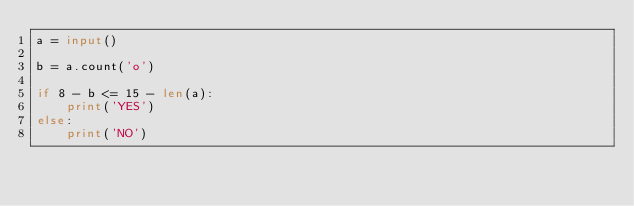<code> <loc_0><loc_0><loc_500><loc_500><_Python_>a = input()

b = a.count('o')

if 8 - b <= 15 - len(a):
    print('YES')
else:
    print('NO')</code> 